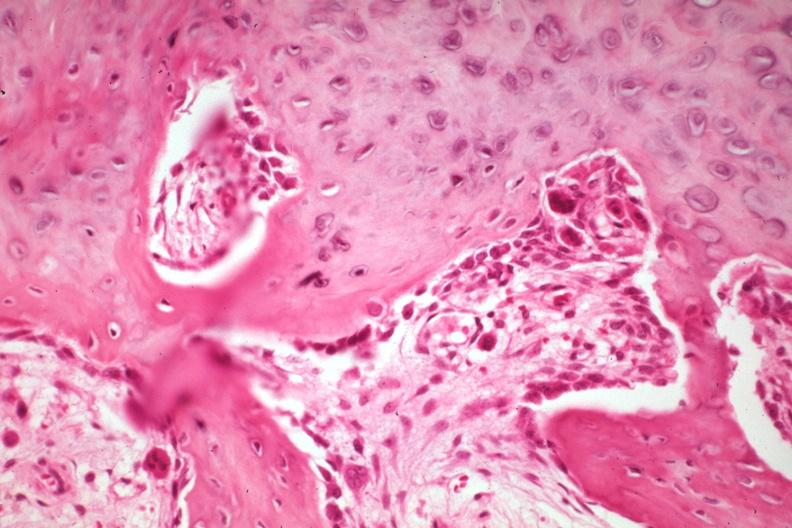what does this image show?
Answer the question using a single word or phrase. High new bone formation with osteoblasts and osteoclasts a good but not the best example 